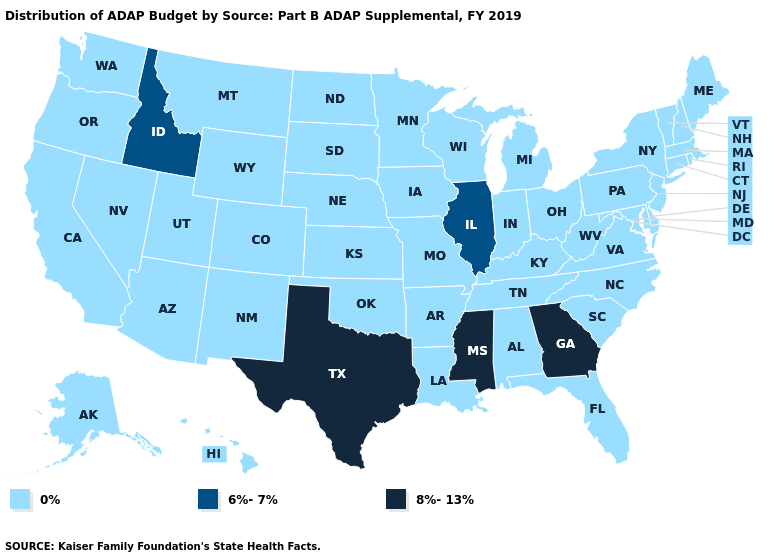Which states have the lowest value in the USA?
Write a very short answer. Alabama, Alaska, Arizona, Arkansas, California, Colorado, Connecticut, Delaware, Florida, Hawaii, Indiana, Iowa, Kansas, Kentucky, Louisiana, Maine, Maryland, Massachusetts, Michigan, Minnesota, Missouri, Montana, Nebraska, Nevada, New Hampshire, New Jersey, New Mexico, New York, North Carolina, North Dakota, Ohio, Oklahoma, Oregon, Pennsylvania, Rhode Island, South Carolina, South Dakota, Tennessee, Utah, Vermont, Virginia, Washington, West Virginia, Wisconsin, Wyoming. Among the states that border Nevada , which have the lowest value?
Answer briefly. Arizona, California, Oregon, Utah. What is the value of Vermont?
Concise answer only. 0%. Does Tennessee have the same value as Georgia?
Short answer required. No. Does the map have missing data?
Give a very brief answer. No. What is the value of Oklahoma?
Quick response, please. 0%. What is the value of New Hampshire?
Keep it brief. 0%. Which states have the highest value in the USA?
Quick response, please. Georgia, Mississippi, Texas. Name the states that have a value in the range 6%-7%?
Concise answer only. Idaho, Illinois. Name the states that have a value in the range 8%-13%?
Write a very short answer. Georgia, Mississippi, Texas. What is the highest value in the USA?
Keep it brief. 8%-13%. Name the states that have a value in the range 8%-13%?
Write a very short answer. Georgia, Mississippi, Texas. What is the value of Rhode Island?
Be succinct. 0%. Does Kansas have the highest value in the USA?
Be succinct. No. 